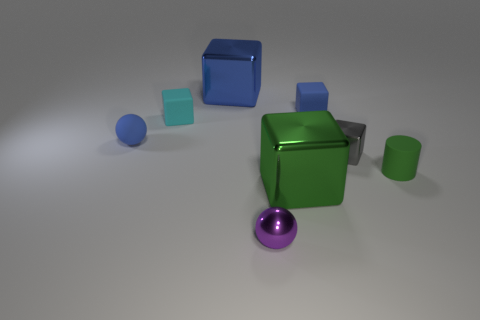Subtract all blue metal cubes. How many cubes are left? 4 Subtract 1 cubes. How many cubes are left? 4 Subtract all green blocks. How many blocks are left? 4 Add 2 small cyan objects. How many objects exist? 10 Subtract all cyan blocks. Subtract all blue spheres. How many blocks are left? 4 Subtract all spheres. How many objects are left? 6 Subtract all green things. Subtract all cylinders. How many objects are left? 5 Add 1 tiny metal cubes. How many tiny metal cubes are left? 2 Add 7 green rubber objects. How many green rubber objects exist? 8 Subtract 1 purple spheres. How many objects are left? 7 